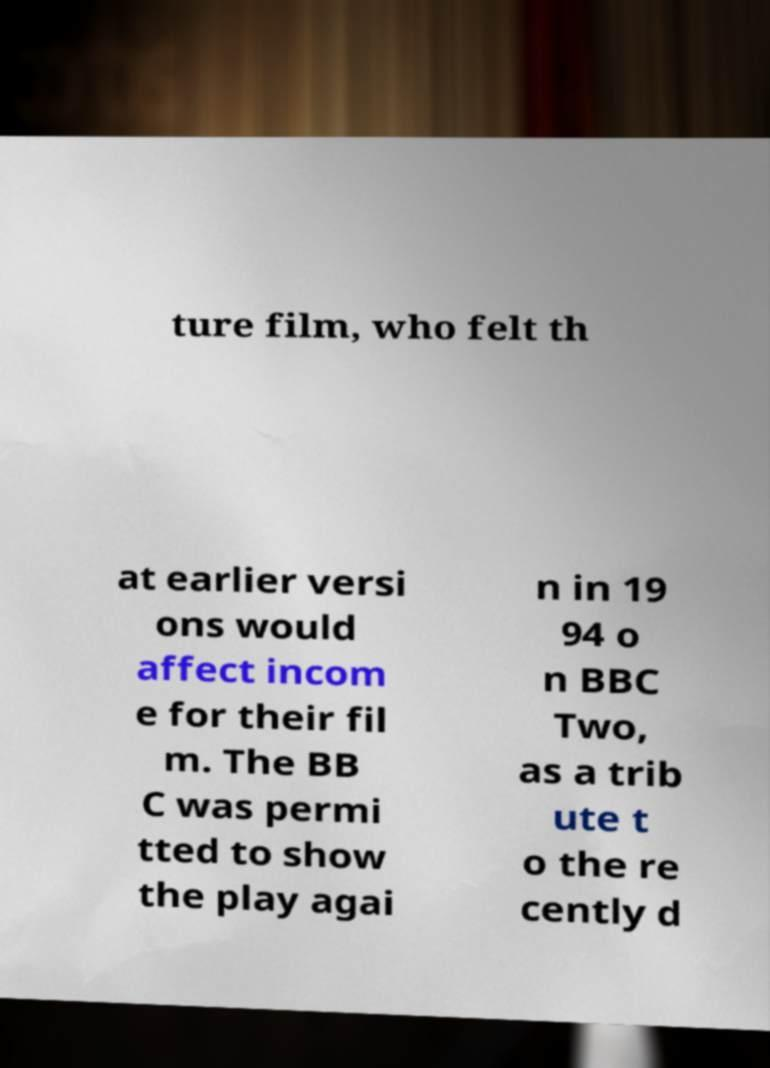Can you read and provide the text displayed in the image?This photo seems to have some interesting text. Can you extract and type it out for me? ture film, who felt th at earlier versi ons would affect incom e for their fil m. The BB C was permi tted to show the play agai n in 19 94 o n BBC Two, as a trib ute t o the re cently d 